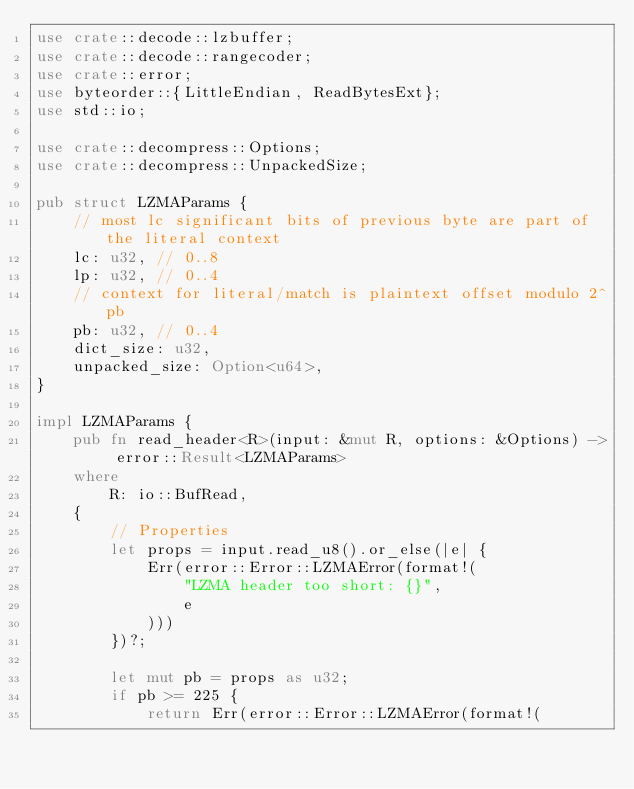<code> <loc_0><loc_0><loc_500><loc_500><_Rust_>use crate::decode::lzbuffer;
use crate::decode::rangecoder;
use crate::error;
use byteorder::{LittleEndian, ReadBytesExt};
use std::io;

use crate::decompress::Options;
use crate::decompress::UnpackedSize;

pub struct LZMAParams {
    // most lc significant bits of previous byte are part of the literal context
    lc: u32, // 0..8
    lp: u32, // 0..4
    // context for literal/match is plaintext offset modulo 2^pb
    pb: u32, // 0..4
    dict_size: u32,
    unpacked_size: Option<u64>,
}

impl LZMAParams {
    pub fn read_header<R>(input: &mut R, options: &Options) -> error::Result<LZMAParams>
    where
        R: io::BufRead,
    {
        // Properties
        let props = input.read_u8().or_else(|e| {
            Err(error::Error::LZMAError(format!(
                "LZMA header too short: {}",
                e
            )))
        })?;

        let mut pb = props as u32;
        if pb >= 225 {
            return Err(error::Error::LZMAError(format!(</code> 